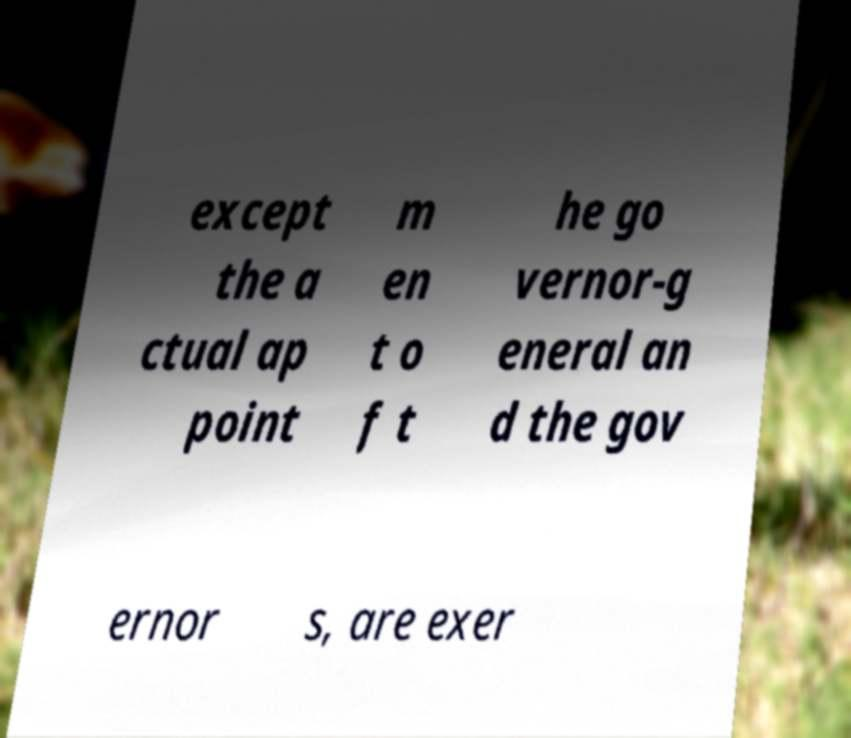Can you accurately transcribe the text from the provided image for me? except the a ctual ap point m en t o f t he go vernor-g eneral an d the gov ernor s, are exer 